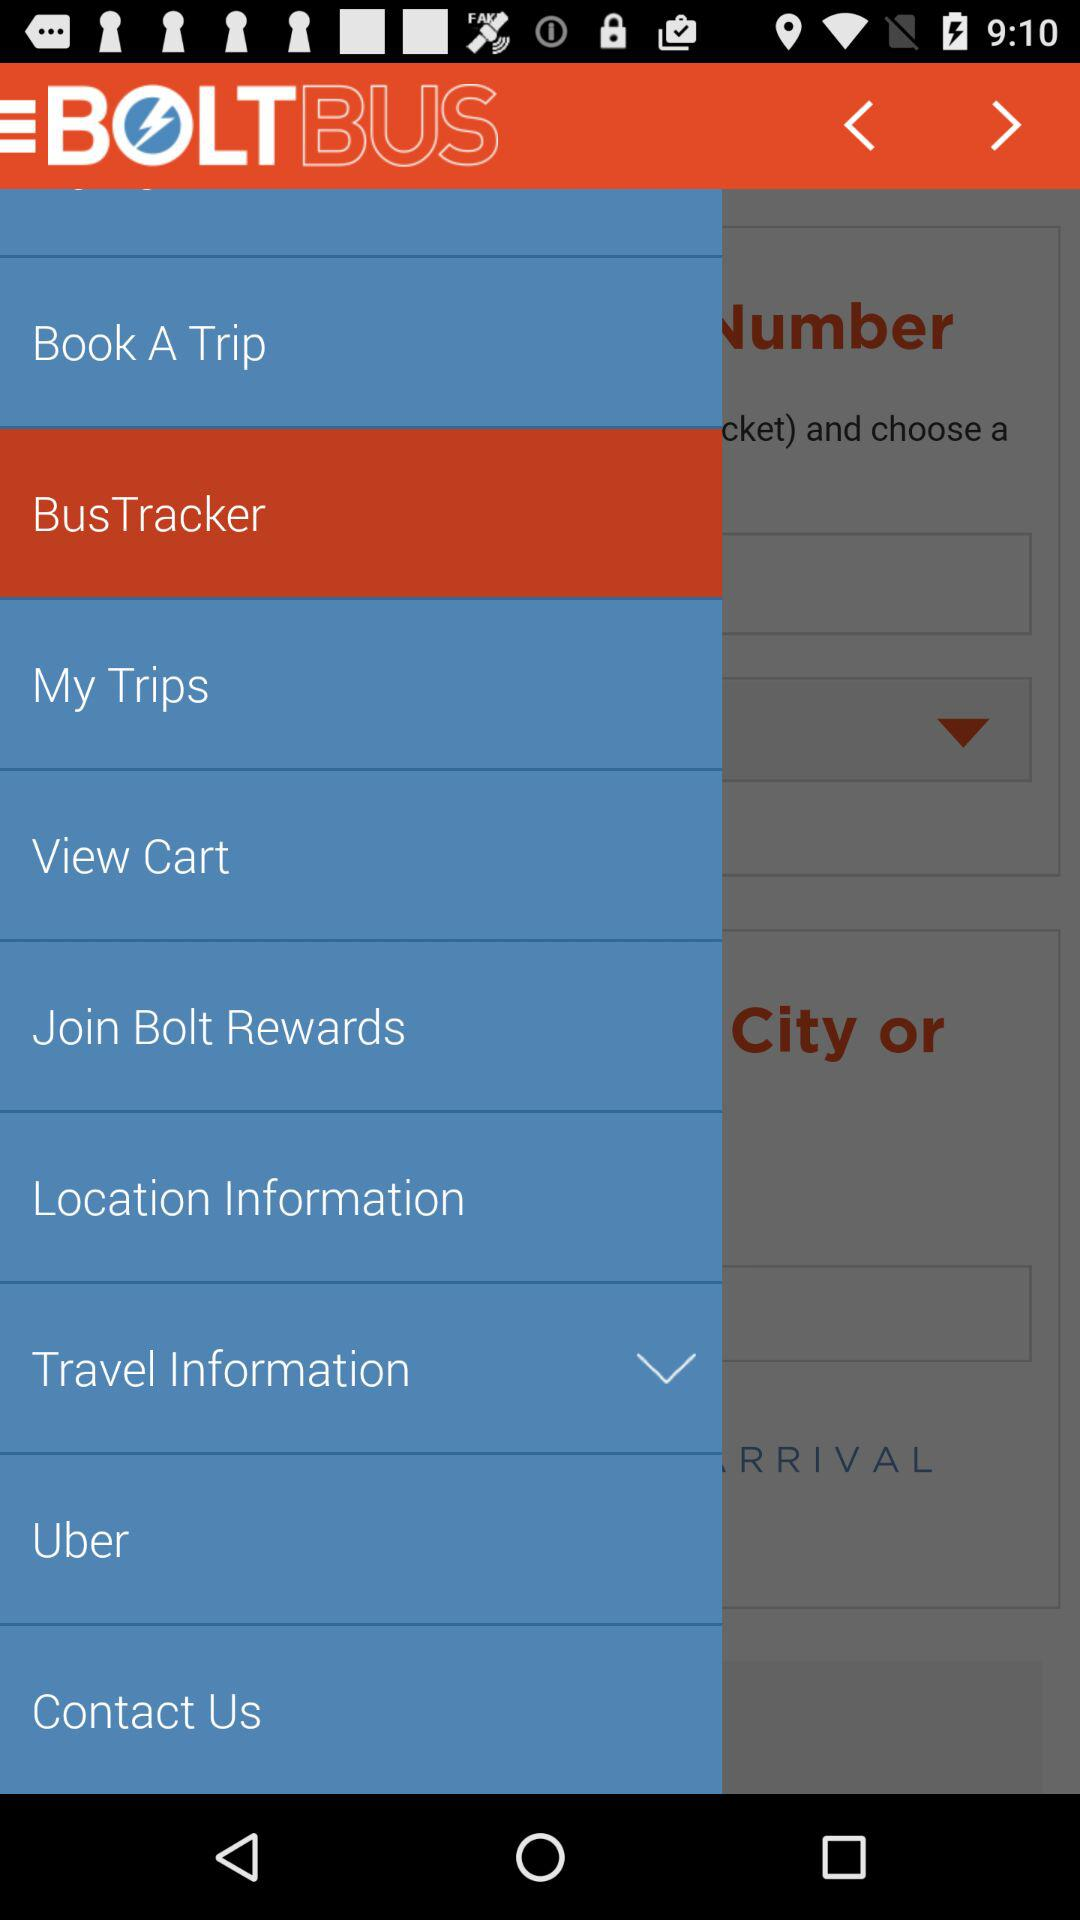When was the application released?
When the provided information is insufficient, respond with <no answer>. <no answer> 